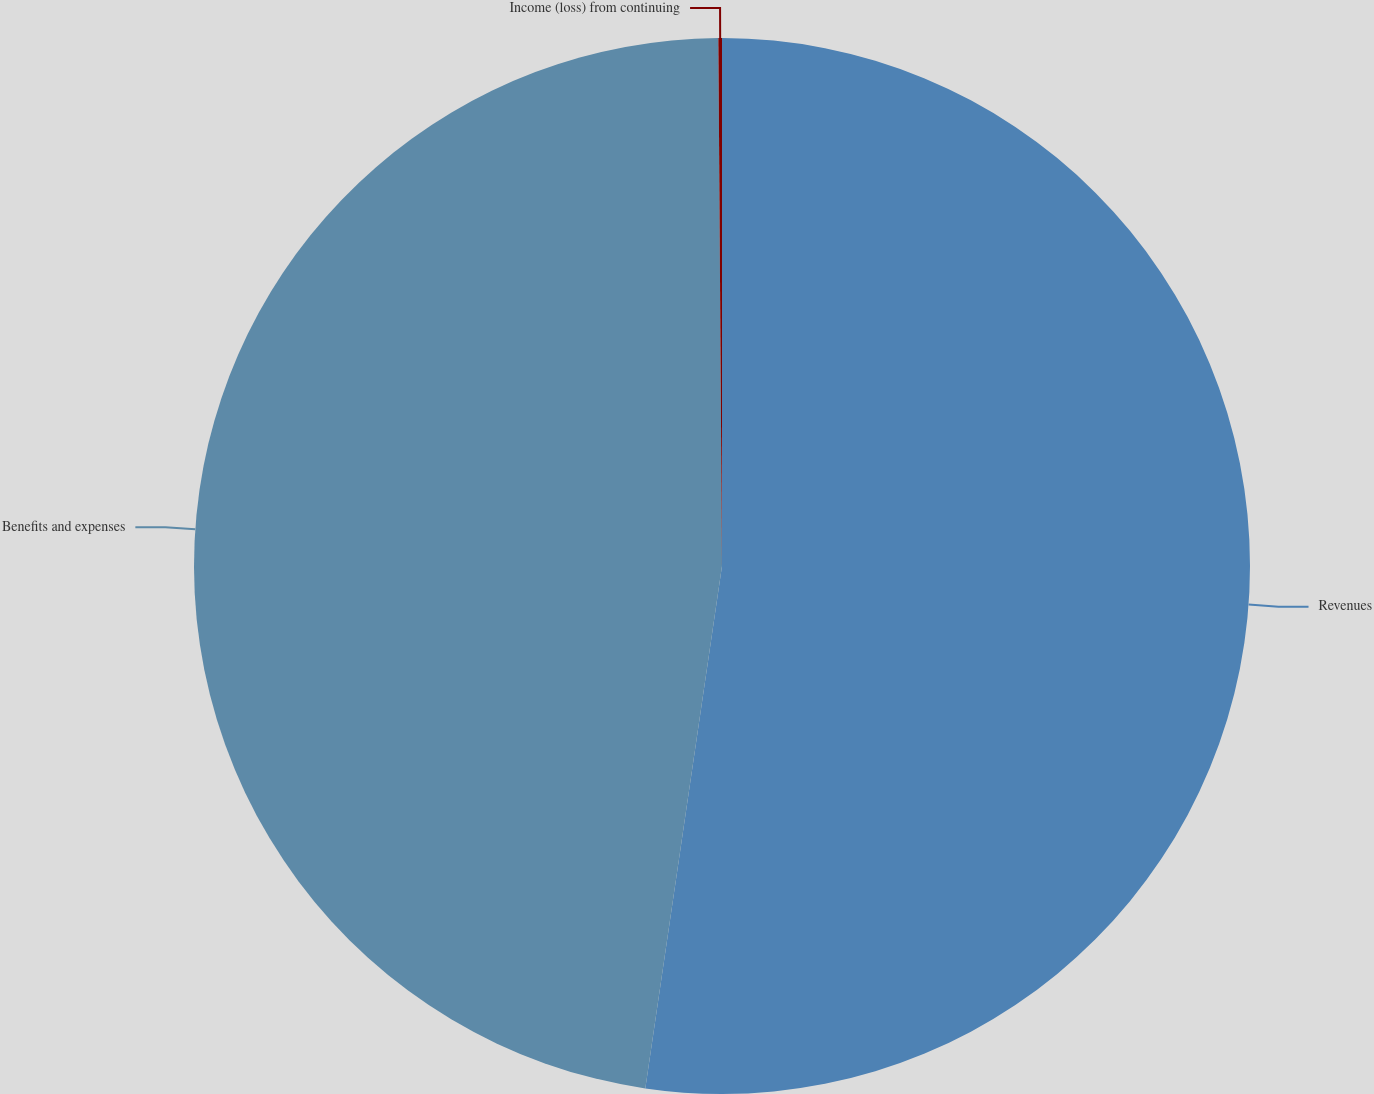Convert chart. <chart><loc_0><loc_0><loc_500><loc_500><pie_chart><fcel>Revenues<fcel>Benefits and expenses<fcel>Income (loss) from continuing<nl><fcel>52.32%<fcel>47.57%<fcel>0.11%<nl></chart> 